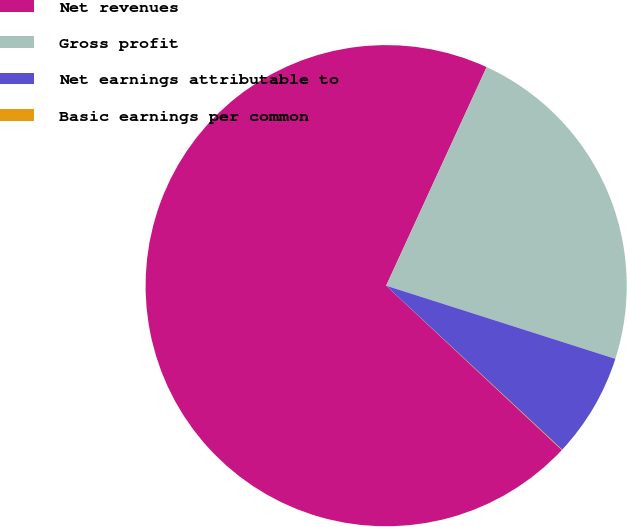Convert chart. <chart><loc_0><loc_0><loc_500><loc_500><pie_chart><fcel>Net revenues<fcel>Gross profit<fcel>Net earnings attributable to<fcel>Basic earnings per common<nl><fcel>69.89%<fcel>23.06%<fcel>7.02%<fcel>0.03%<nl></chart> 